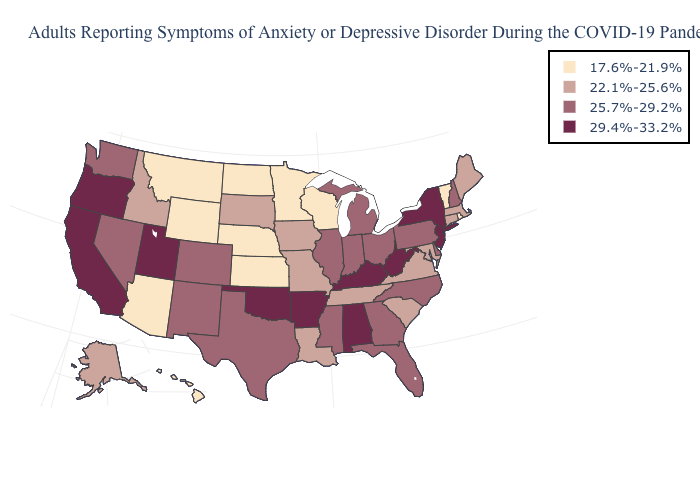How many symbols are there in the legend?
Be succinct. 4. What is the value of Tennessee?
Give a very brief answer. 22.1%-25.6%. Is the legend a continuous bar?
Short answer required. No. Does North Dakota have the highest value in the MidWest?
Give a very brief answer. No. Among the states that border Oklahoma , does Colorado have the lowest value?
Write a very short answer. No. Does South Carolina have the lowest value in the South?
Write a very short answer. Yes. Does the first symbol in the legend represent the smallest category?
Keep it brief. Yes. Does Maine have the highest value in the Northeast?
Write a very short answer. No. What is the value of New Mexico?
Short answer required. 25.7%-29.2%. What is the value of Rhode Island?
Keep it brief. 17.6%-21.9%. Does the map have missing data?
Keep it brief. No. Name the states that have a value in the range 22.1%-25.6%?
Keep it brief. Alaska, Connecticut, Idaho, Iowa, Louisiana, Maine, Maryland, Massachusetts, Missouri, South Carolina, South Dakota, Tennessee, Virginia. Name the states that have a value in the range 17.6%-21.9%?
Quick response, please. Arizona, Hawaii, Kansas, Minnesota, Montana, Nebraska, North Dakota, Rhode Island, Vermont, Wisconsin, Wyoming. Is the legend a continuous bar?
Concise answer only. No. Is the legend a continuous bar?
Short answer required. No. 